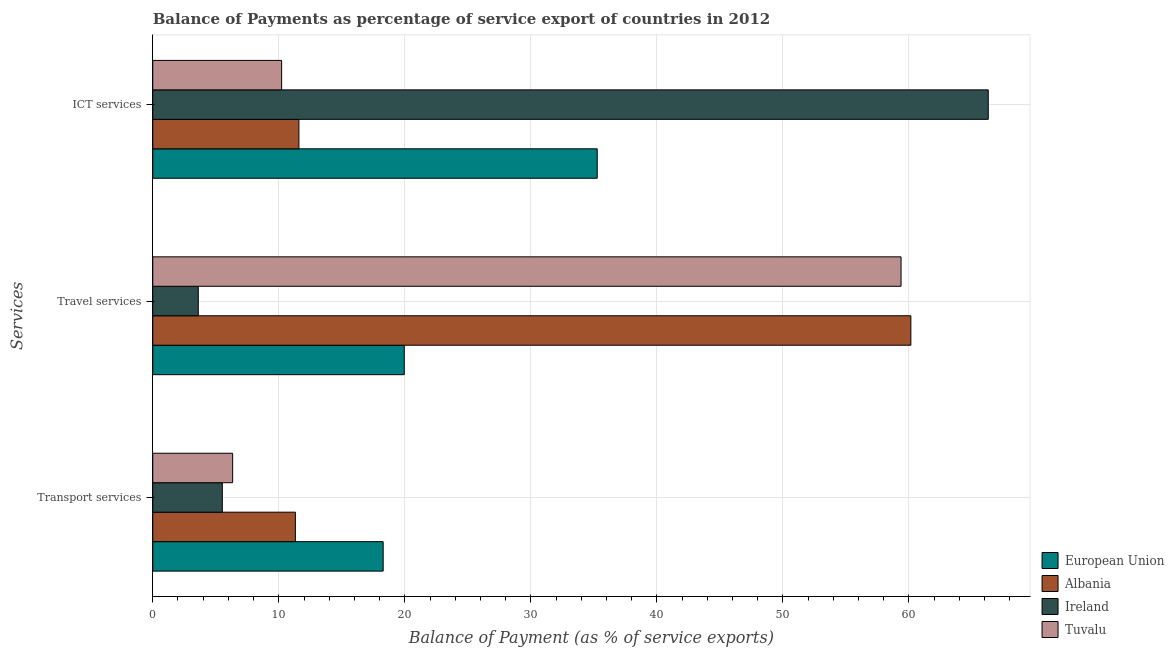How many bars are there on the 3rd tick from the bottom?
Provide a succinct answer. 4. What is the label of the 2nd group of bars from the top?
Offer a terse response. Travel services. What is the balance of payment of travel services in Albania?
Provide a short and direct response. 60.15. Across all countries, what is the maximum balance of payment of ict services?
Offer a very short reply. 66.3. Across all countries, what is the minimum balance of payment of transport services?
Your answer should be compact. 5.52. In which country was the balance of payment of ict services maximum?
Your response must be concise. Ireland. In which country was the balance of payment of travel services minimum?
Offer a very short reply. Ireland. What is the total balance of payment of ict services in the graph?
Offer a terse response. 123.38. What is the difference between the balance of payment of transport services in European Union and that in Tuvalu?
Make the answer very short. 11.94. What is the difference between the balance of payment of transport services in European Union and the balance of payment of ict services in Albania?
Your answer should be compact. 6.69. What is the average balance of payment of travel services per country?
Offer a terse response. 35.77. What is the difference between the balance of payment of transport services and balance of payment of ict services in European Union?
Make the answer very short. -16.98. In how many countries, is the balance of payment of transport services greater than 22 %?
Give a very brief answer. 0. What is the ratio of the balance of payment of travel services in Ireland to that in Albania?
Your answer should be very brief. 0.06. Is the balance of payment of transport services in Ireland less than that in European Union?
Provide a succinct answer. Yes. Is the difference between the balance of payment of travel services in European Union and Tuvalu greater than the difference between the balance of payment of transport services in European Union and Tuvalu?
Offer a terse response. No. What is the difference between the highest and the second highest balance of payment of ict services?
Provide a succinct answer. 31.03. What is the difference between the highest and the lowest balance of payment of transport services?
Your answer should be very brief. 12.76. In how many countries, is the balance of payment of ict services greater than the average balance of payment of ict services taken over all countries?
Offer a very short reply. 2. What does the 2nd bar from the top in Transport services represents?
Give a very brief answer. Ireland. What does the 4th bar from the bottom in Travel services represents?
Your answer should be compact. Tuvalu. Is it the case that in every country, the sum of the balance of payment of transport services and balance of payment of travel services is greater than the balance of payment of ict services?
Make the answer very short. No. How many bars are there?
Give a very brief answer. 12. Are all the bars in the graph horizontal?
Your response must be concise. Yes. Are the values on the major ticks of X-axis written in scientific E-notation?
Your response must be concise. No. How many legend labels are there?
Offer a very short reply. 4. How are the legend labels stacked?
Provide a short and direct response. Vertical. What is the title of the graph?
Make the answer very short. Balance of Payments as percentage of service export of countries in 2012. Does "Estonia" appear as one of the legend labels in the graph?
Ensure brevity in your answer.  No. What is the label or title of the X-axis?
Keep it short and to the point. Balance of Payment (as % of service exports). What is the label or title of the Y-axis?
Offer a terse response. Services. What is the Balance of Payment (as % of service exports) of European Union in Transport services?
Offer a terse response. 18.28. What is the Balance of Payment (as % of service exports) of Albania in Transport services?
Keep it short and to the point. 11.31. What is the Balance of Payment (as % of service exports) in Ireland in Transport services?
Give a very brief answer. 5.52. What is the Balance of Payment (as % of service exports) of Tuvalu in Transport services?
Offer a very short reply. 6.34. What is the Balance of Payment (as % of service exports) of European Union in Travel services?
Your answer should be very brief. 19.96. What is the Balance of Payment (as % of service exports) in Albania in Travel services?
Your response must be concise. 60.15. What is the Balance of Payment (as % of service exports) of Ireland in Travel services?
Ensure brevity in your answer.  3.61. What is the Balance of Payment (as % of service exports) in Tuvalu in Travel services?
Make the answer very short. 59.37. What is the Balance of Payment (as % of service exports) in European Union in ICT services?
Offer a terse response. 35.27. What is the Balance of Payment (as % of service exports) in Albania in ICT services?
Give a very brief answer. 11.59. What is the Balance of Payment (as % of service exports) of Ireland in ICT services?
Your answer should be compact. 66.3. What is the Balance of Payment (as % of service exports) in Tuvalu in ICT services?
Offer a terse response. 10.22. Across all Services, what is the maximum Balance of Payment (as % of service exports) in European Union?
Offer a very short reply. 35.27. Across all Services, what is the maximum Balance of Payment (as % of service exports) of Albania?
Offer a very short reply. 60.15. Across all Services, what is the maximum Balance of Payment (as % of service exports) in Ireland?
Provide a succinct answer. 66.3. Across all Services, what is the maximum Balance of Payment (as % of service exports) of Tuvalu?
Your answer should be very brief. 59.37. Across all Services, what is the minimum Balance of Payment (as % of service exports) in European Union?
Make the answer very short. 18.28. Across all Services, what is the minimum Balance of Payment (as % of service exports) of Albania?
Give a very brief answer. 11.31. Across all Services, what is the minimum Balance of Payment (as % of service exports) in Ireland?
Keep it short and to the point. 3.61. Across all Services, what is the minimum Balance of Payment (as % of service exports) in Tuvalu?
Your answer should be very brief. 6.34. What is the total Balance of Payment (as % of service exports) in European Union in the graph?
Make the answer very short. 73.5. What is the total Balance of Payment (as % of service exports) in Albania in the graph?
Ensure brevity in your answer.  83.06. What is the total Balance of Payment (as % of service exports) in Ireland in the graph?
Offer a terse response. 75.43. What is the total Balance of Payment (as % of service exports) of Tuvalu in the graph?
Provide a short and direct response. 75.94. What is the difference between the Balance of Payment (as % of service exports) of European Union in Transport services and that in Travel services?
Your response must be concise. -1.67. What is the difference between the Balance of Payment (as % of service exports) of Albania in Transport services and that in Travel services?
Your answer should be compact. -48.84. What is the difference between the Balance of Payment (as % of service exports) in Ireland in Transport services and that in Travel services?
Your response must be concise. 1.91. What is the difference between the Balance of Payment (as % of service exports) of Tuvalu in Transport services and that in Travel services?
Ensure brevity in your answer.  -53.04. What is the difference between the Balance of Payment (as % of service exports) in European Union in Transport services and that in ICT services?
Give a very brief answer. -16.98. What is the difference between the Balance of Payment (as % of service exports) of Albania in Transport services and that in ICT services?
Your answer should be compact. -0.28. What is the difference between the Balance of Payment (as % of service exports) in Ireland in Transport services and that in ICT services?
Offer a very short reply. -60.78. What is the difference between the Balance of Payment (as % of service exports) in Tuvalu in Transport services and that in ICT services?
Offer a terse response. -3.89. What is the difference between the Balance of Payment (as % of service exports) of European Union in Travel services and that in ICT services?
Keep it short and to the point. -15.31. What is the difference between the Balance of Payment (as % of service exports) of Albania in Travel services and that in ICT services?
Ensure brevity in your answer.  48.56. What is the difference between the Balance of Payment (as % of service exports) in Ireland in Travel services and that in ICT services?
Provide a succinct answer. -62.68. What is the difference between the Balance of Payment (as % of service exports) in Tuvalu in Travel services and that in ICT services?
Offer a very short reply. 49.15. What is the difference between the Balance of Payment (as % of service exports) of European Union in Transport services and the Balance of Payment (as % of service exports) of Albania in Travel services?
Provide a succinct answer. -41.87. What is the difference between the Balance of Payment (as % of service exports) in European Union in Transport services and the Balance of Payment (as % of service exports) in Ireland in Travel services?
Make the answer very short. 14.67. What is the difference between the Balance of Payment (as % of service exports) of European Union in Transport services and the Balance of Payment (as % of service exports) of Tuvalu in Travel services?
Your response must be concise. -41.09. What is the difference between the Balance of Payment (as % of service exports) of Albania in Transport services and the Balance of Payment (as % of service exports) of Ireland in Travel services?
Make the answer very short. 7.7. What is the difference between the Balance of Payment (as % of service exports) of Albania in Transport services and the Balance of Payment (as % of service exports) of Tuvalu in Travel services?
Make the answer very short. -48.06. What is the difference between the Balance of Payment (as % of service exports) in Ireland in Transport services and the Balance of Payment (as % of service exports) in Tuvalu in Travel services?
Keep it short and to the point. -53.86. What is the difference between the Balance of Payment (as % of service exports) of European Union in Transport services and the Balance of Payment (as % of service exports) of Albania in ICT services?
Offer a terse response. 6.69. What is the difference between the Balance of Payment (as % of service exports) in European Union in Transport services and the Balance of Payment (as % of service exports) in Ireland in ICT services?
Provide a succinct answer. -48.01. What is the difference between the Balance of Payment (as % of service exports) in European Union in Transport services and the Balance of Payment (as % of service exports) in Tuvalu in ICT services?
Give a very brief answer. 8.06. What is the difference between the Balance of Payment (as % of service exports) in Albania in Transport services and the Balance of Payment (as % of service exports) in Ireland in ICT services?
Ensure brevity in your answer.  -54.98. What is the difference between the Balance of Payment (as % of service exports) in Albania in Transport services and the Balance of Payment (as % of service exports) in Tuvalu in ICT services?
Offer a very short reply. 1.09. What is the difference between the Balance of Payment (as % of service exports) of Ireland in Transport services and the Balance of Payment (as % of service exports) of Tuvalu in ICT services?
Keep it short and to the point. -4.71. What is the difference between the Balance of Payment (as % of service exports) of European Union in Travel services and the Balance of Payment (as % of service exports) of Albania in ICT services?
Give a very brief answer. 8.36. What is the difference between the Balance of Payment (as % of service exports) of European Union in Travel services and the Balance of Payment (as % of service exports) of Ireland in ICT services?
Offer a very short reply. -46.34. What is the difference between the Balance of Payment (as % of service exports) in European Union in Travel services and the Balance of Payment (as % of service exports) in Tuvalu in ICT services?
Ensure brevity in your answer.  9.73. What is the difference between the Balance of Payment (as % of service exports) in Albania in Travel services and the Balance of Payment (as % of service exports) in Ireland in ICT services?
Offer a very short reply. -6.14. What is the difference between the Balance of Payment (as % of service exports) in Albania in Travel services and the Balance of Payment (as % of service exports) in Tuvalu in ICT services?
Your answer should be very brief. 49.93. What is the difference between the Balance of Payment (as % of service exports) of Ireland in Travel services and the Balance of Payment (as % of service exports) of Tuvalu in ICT services?
Offer a very short reply. -6.61. What is the average Balance of Payment (as % of service exports) of European Union per Services?
Offer a very short reply. 24.5. What is the average Balance of Payment (as % of service exports) in Albania per Services?
Offer a very short reply. 27.69. What is the average Balance of Payment (as % of service exports) of Ireland per Services?
Your answer should be very brief. 25.14. What is the average Balance of Payment (as % of service exports) of Tuvalu per Services?
Keep it short and to the point. 25.31. What is the difference between the Balance of Payment (as % of service exports) in European Union and Balance of Payment (as % of service exports) in Albania in Transport services?
Provide a succinct answer. 6.97. What is the difference between the Balance of Payment (as % of service exports) in European Union and Balance of Payment (as % of service exports) in Ireland in Transport services?
Make the answer very short. 12.76. What is the difference between the Balance of Payment (as % of service exports) of European Union and Balance of Payment (as % of service exports) of Tuvalu in Transport services?
Give a very brief answer. 11.94. What is the difference between the Balance of Payment (as % of service exports) in Albania and Balance of Payment (as % of service exports) in Ireland in Transport services?
Your answer should be very brief. 5.8. What is the difference between the Balance of Payment (as % of service exports) of Albania and Balance of Payment (as % of service exports) of Tuvalu in Transport services?
Give a very brief answer. 4.98. What is the difference between the Balance of Payment (as % of service exports) in Ireland and Balance of Payment (as % of service exports) in Tuvalu in Transport services?
Keep it short and to the point. -0.82. What is the difference between the Balance of Payment (as % of service exports) in European Union and Balance of Payment (as % of service exports) in Albania in Travel services?
Your answer should be compact. -40.2. What is the difference between the Balance of Payment (as % of service exports) of European Union and Balance of Payment (as % of service exports) of Ireland in Travel services?
Give a very brief answer. 16.34. What is the difference between the Balance of Payment (as % of service exports) in European Union and Balance of Payment (as % of service exports) in Tuvalu in Travel services?
Ensure brevity in your answer.  -39.42. What is the difference between the Balance of Payment (as % of service exports) in Albania and Balance of Payment (as % of service exports) in Ireland in Travel services?
Offer a terse response. 56.54. What is the difference between the Balance of Payment (as % of service exports) in Albania and Balance of Payment (as % of service exports) in Tuvalu in Travel services?
Your answer should be compact. 0.78. What is the difference between the Balance of Payment (as % of service exports) of Ireland and Balance of Payment (as % of service exports) of Tuvalu in Travel services?
Offer a very short reply. -55.76. What is the difference between the Balance of Payment (as % of service exports) in European Union and Balance of Payment (as % of service exports) in Albania in ICT services?
Give a very brief answer. 23.67. What is the difference between the Balance of Payment (as % of service exports) of European Union and Balance of Payment (as % of service exports) of Ireland in ICT services?
Make the answer very short. -31.03. What is the difference between the Balance of Payment (as % of service exports) in European Union and Balance of Payment (as % of service exports) in Tuvalu in ICT services?
Ensure brevity in your answer.  25.04. What is the difference between the Balance of Payment (as % of service exports) of Albania and Balance of Payment (as % of service exports) of Ireland in ICT services?
Ensure brevity in your answer.  -54.7. What is the difference between the Balance of Payment (as % of service exports) of Albania and Balance of Payment (as % of service exports) of Tuvalu in ICT services?
Ensure brevity in your answer.  1.37. What is the difference between the Balance of Payment (as % of service exports) in Ireland and Balance of Payment (as % of service exports) in Tuvalu in ICT services?
Make the answer very short. 56.07. What is the ratio of the Balance of Payment (as % of service exports) in European Union in Transport services to that in Travel services?
Provide a short and direct response. 0.92. What is the ratio of the Balance of Payment (as % of service exports) of Albania in Transport services to that in Travel services?
Your response must be concise. 0.19. What is the ratio of the Balance of Payment (as % of service exports) in Ireland in Transport services to that in Travel services?
Provide a succinct answer. 1.53. What is the ratio of the Balance of Payment (as % of service exports) in Tuvalu in Transport services to that in Travel services?
Give a very brief answer. 0.11. What is the ratio of the Balance of Payment (as % of service exports) in European Union in Transport services to that in ICT services?
Make the answer very short. 0.52. What is the ratio of the Balance of Payment (as % of service exports) of Albania in Transport services to that in ICT services?
Ensure brevity in your answer.  0.98. What is the ratio of the Balance of Payment (as % of service exports) in Ireland in Transport services to that in ICT services?
Provide a succinct answer. 0.08. What is the ratio of the Balance of Payment (as % of service exports) of Tuvalu in Transport services to that in ICT services?
Give a very brief answer. 0.62. What is the ratio of the Balance of Payment (as % of service exports) in European Union in Travel services to that in ICT services?
Your response must be concise. 0.57. What is the ratio of the Balance of Payment (as % of service exports) of Albania in Travel services to that in ICT services?
Your response must be concise. 5.19. What is the ratio of the Balance of Payment (as % of service exports) in Ireland in Travel services to that in ICT services?
Offer a terse response. 0.05. What is the ratio of the Balance of Payment (as % of service exports) in Tuvalu in Travel services to that in ICT services?
Provide a succinct answer. 5.81. What is the difference between the highest and the second highest Balance of Payment (as % of service exports) in European Union?
Offer a terse response. 15.31. What is the difference between the highest and the second highest Balance of Payment (as % of service exports) in Albania?
Ensure brevity in your answer.  48.56. What is the difference between the highest and the second highest Balance of Payment (as % of service exports) of Ireland?
Ensure brevity in your answer.  60.78. What is the difference between the highest and the second highest Balance of Payment (as % of service exports) in Tuvalu?
Keep it short and to the point. 49.15. What is the difference between the highest and the lowest Balance of Payment (as % of service exports) in European Union?
Offer a terse response. 16.98. What is the difference between the highest and the lowest Balance of Payment (as % of service exports) of Albania?
Your answer should be compact. 48.84. What is the difference between the highest and the lowest Balance of Payment (as % of service exports) of Ireland?
Your response must be concise. 62.68. What is the difference between the highest and the lowest Balance of Payment (as % of service exports) in Tuvalu?
Offer a very short reply. 53.04. 